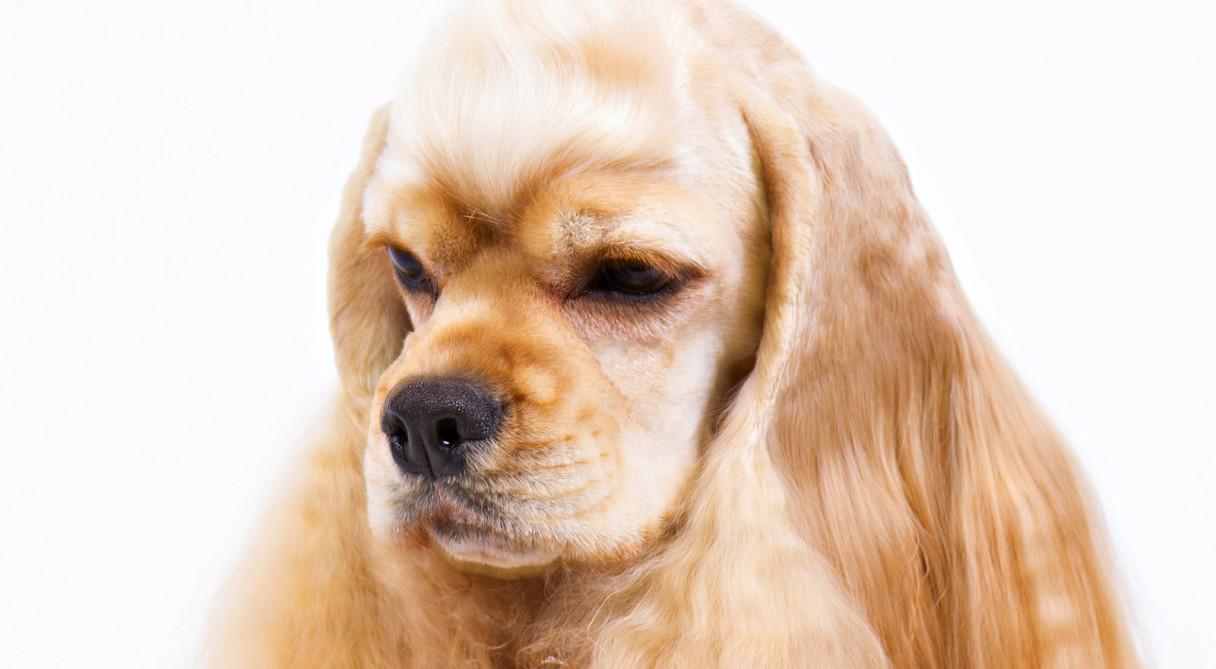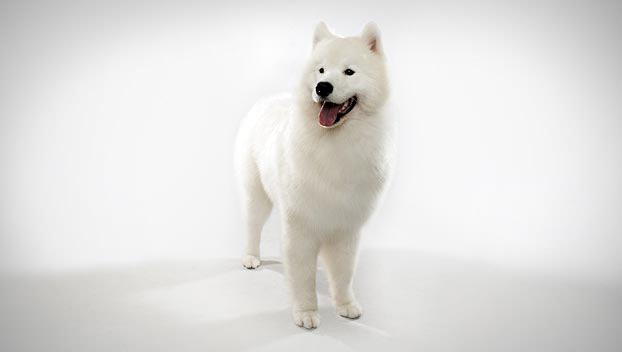The first image is the image on the left, the second image is the image on the right. Considering the images on both sides, is "The image contains a full bodied white dog, with brown ears, looking left." valid? Answer yes or no. No. The first image is the image on the left, the second image is the image on the right. Considering the images on both sides, is "There are at most two dogs." valid? Answer yes or no. Yes. 